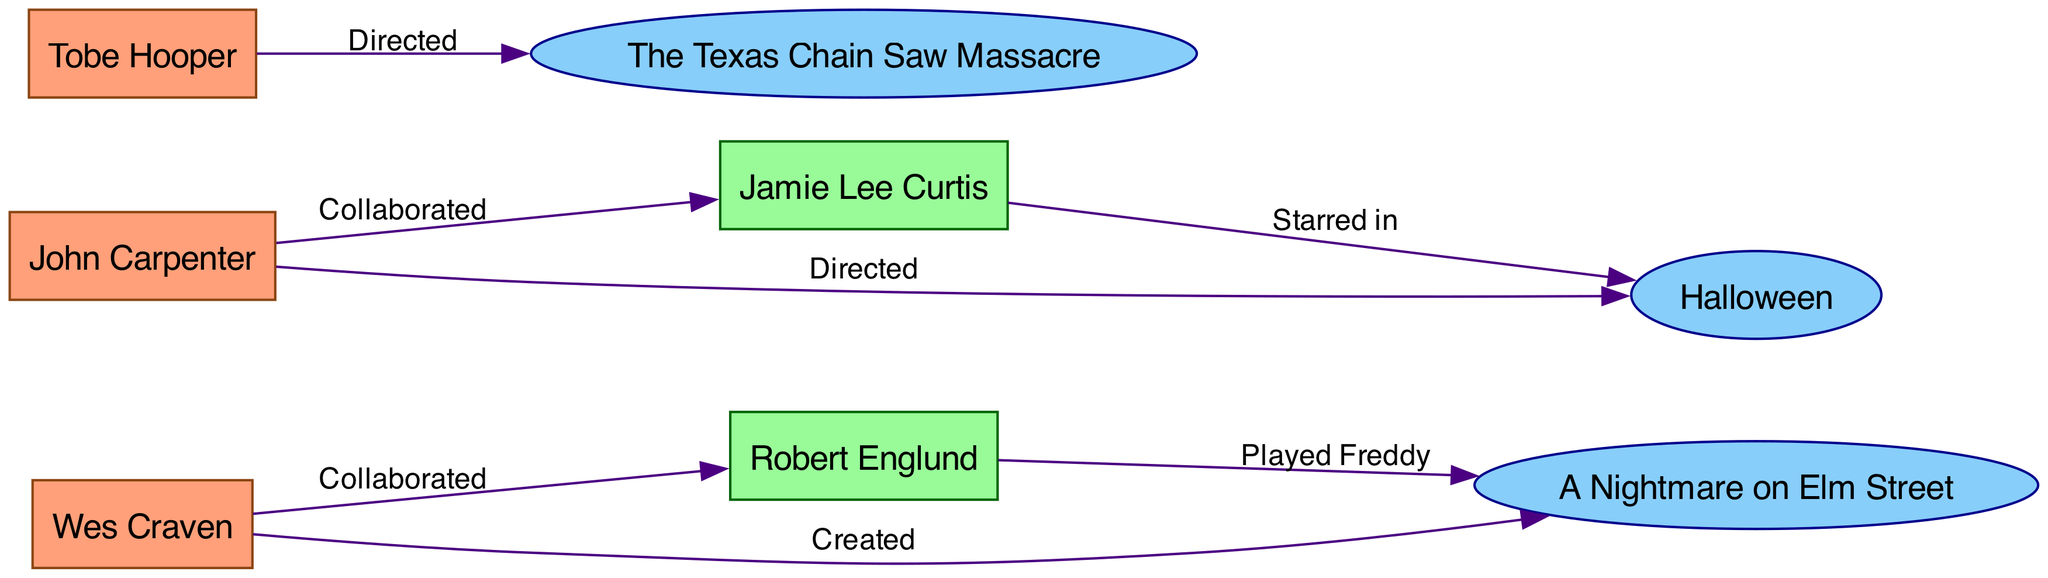What are the names of the three directors in the diagram? The diagram lists three directors: Wes Craven, John Carpenter, and Tobe Hooper. I identified them by searching for nodes labeled as "Director."
Answer: Wes Craven, John Carpenter, Tobe Hooper Which franchise is Wes Craven associated with? According to the edges, Wes Craven is directly connected to the "A Nightmare on Elm Street" franchise, as indicated by the edge labeled "Created."
Answer: A Nightmare on Elm Street Who starred in the "Halloween" franchise? Jamie Lee Curtis is directly connected to the "Halloween" franchise as shown by the edge labeled "Starred in." This is confirmed by the connection from the actor node to the franchise node.
Answer: Jamie Lee Curtis How many edges are in the diagram? To find the number of edges, I counted the connections between nodes, which is represented as lines in the diagram. There are a total of 6 edges connecting the nodes.
Answer: 6 Which actor played Freddy Krueger? The diagram indicates that Robert Englund has an edge connected to "A Nightmare on Elm Street" labeled "Played Freddy." Thus, he is the one who played Freddy Krueger.
Answer: Robert Englund How many franchises are represented in the diagram? I examined the nodes specifically labeled as "Franchise." There are three such nodes in the diagram: Halloween, A Nightmare on Elm Street, and The Texas Chain Saw Massacre. Therefore, the total count is three.
Answer: 3 Which director collaborated with Jamie Lee Curtis? By checking the edges, I see that John Carpenter is the director who collaborated with Jamie Lee Curtis, as indicated by the edge labeled "Collaborated."
Answer: John Carpenter What relationships exist between Tobe Hooper and any franchises? The edge labeled "Directed" links Tobe Hooper to "The Texas Chain Saw Massacre" franchise. This shows Tobe Hooper's directorial connection to that franchise.
Answer: Directed The Texas Chain Saw Massacre How many actors are in the diagram? I checked the nodes specifically marked as "Actor." There are two actors: Jamie Lee Curtis and Robert Englund. Thus, the count is two actors.
Answer: 2 